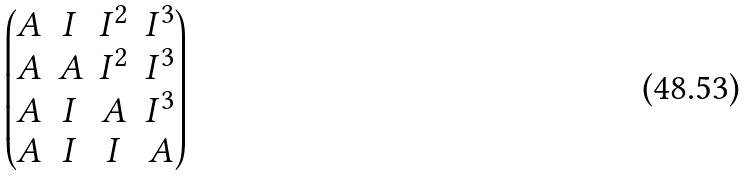Convert formula to latex. <formula><loc_0><loc_0><loc_500><loc_500>\begin{pmatrix} A & I & I ^ { 2 } & I ^ { 3 } \\ A & A & I ^ { 2 } & I ^ { 3 } \\ A & I & A & I ^ { 3 } \\ A & I & I & A \end{pmatrix}</formula> 